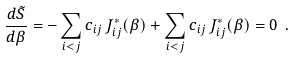<formula> <loc_0><loc_0><loc_500><loc_500>\frac { d \tilde { S } } { d \beta } = - \sum _ { i < j } c _ { i j } \, J _ { i j } ^ { * } ( \beta ) + \sum _ { i < j } c _ { i j } \, J _ { i j } ^ { * } ( \beta ) = 0 \ .</formula> 